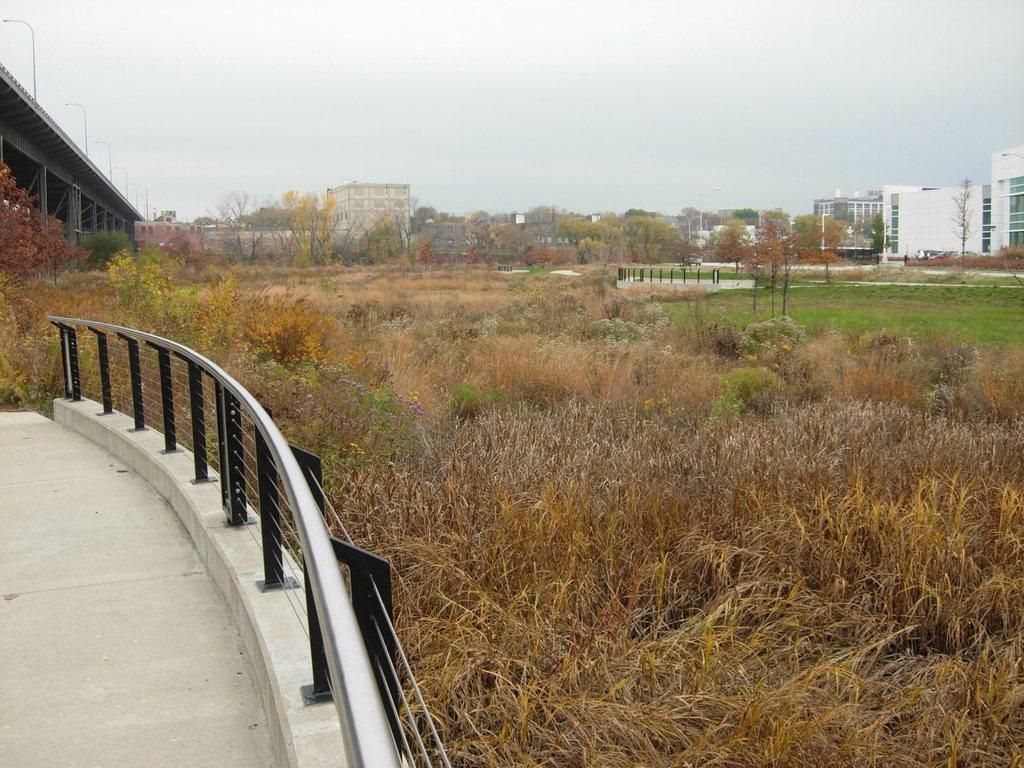What type of material is used for the railing in the image? The railing in the image is made of steel. What type of vegetation can be seen in the image? There is dry grass and grass visible in the image. What structure is located on the left side of the image? There is a bridge on the left side of the image. What can be seen in the background of the image? There are trees, buildings, and the sky visible in the background of the image. Where is the vase located in the image? There is no vase present in the image. What type of road can be seen in the image? There is no road visible in the image. 